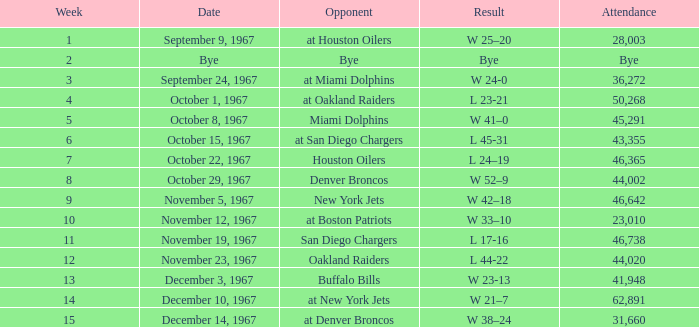When was the game that took place after the week 5 match against the houston oilers? October 22, 1967. 